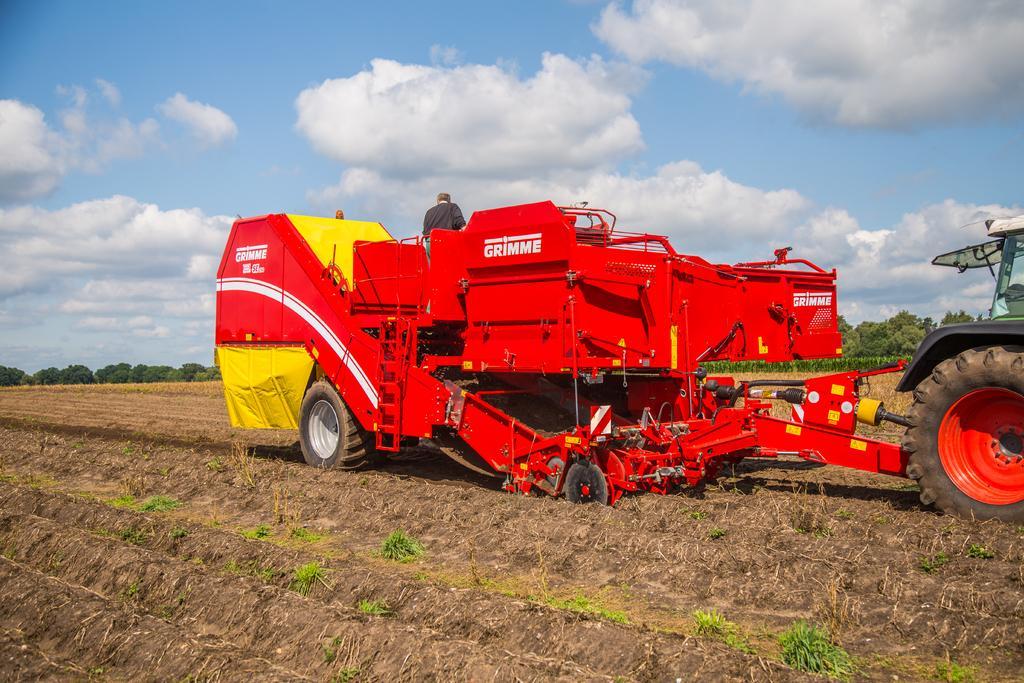Please provide a concise description of this image. Here in this picture we can see a potato harvester present in a field and we can see grass present in the field and in the far we can see plants and trees present and we can see clouds in the sky and we can also see a person present in the vehicle. 